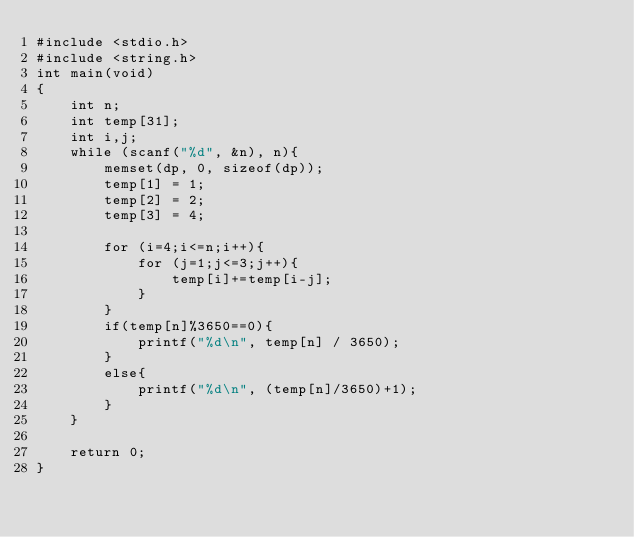<code> <loc_0><loc_0><loc_500><loc_500><_C_>#include <stdio.h>
#include <string.h>
int main(void)
{
    int n;
    int temp[31];
    int i,j;
    while (scanf("%d", &n), n){
        memset(dp, 0, sizeof(dp));
        temp[1] = 1;
        temp[2] = 2;
        temp[3] = 4;
 
        for (i=4;i<=n;i++){
            for (j=1;j<=3;j++){
                temp[i]+=temp[i-j];
            }
        }
        if(temp[n]%3650==0){
            printf("%d\n", temp[n] / 3650);
        }
        else{
            printf("%d\n", (temp[n]/3650)+1);
        }
    }
 
    return 0;
}</code> 